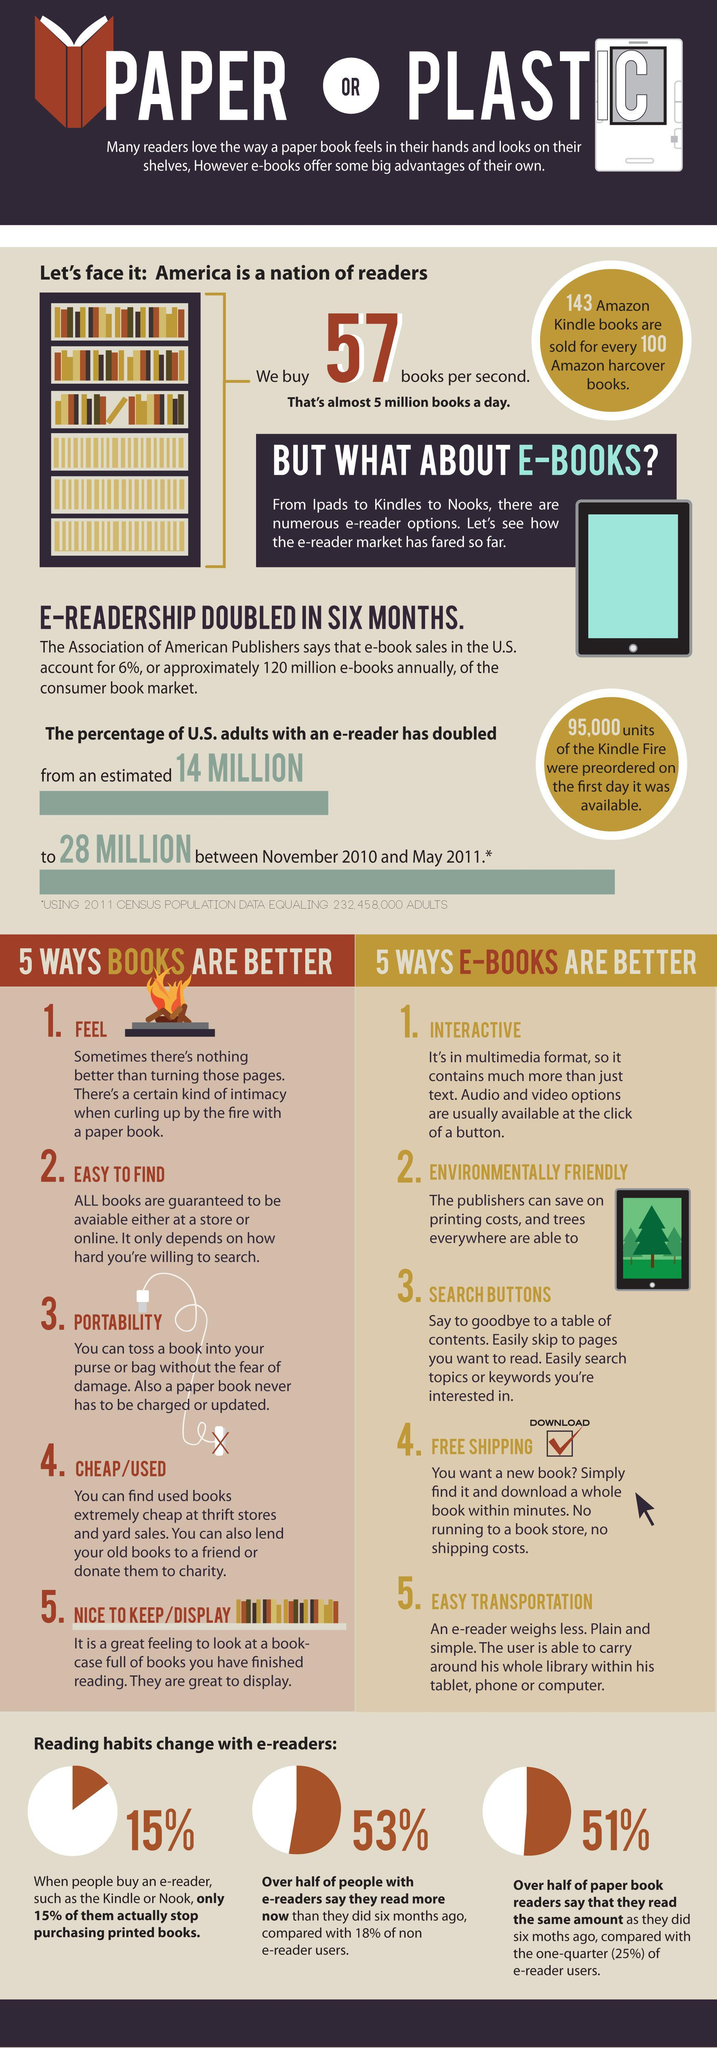What percentage of paper book readers in the U.S. say that they read the same amount as they did six months ago?
Answer the question with a short phrase. 51% What percentage of e-readers in the U.S. say that they read more than they did six months ago? 53% 